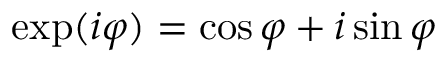Convert formula to latex. <formula><loc_0><loc_0><loc_500><loc_500>\exp ( i \varphi ) = \cos \varphi + i \sin \varphi</formula> 